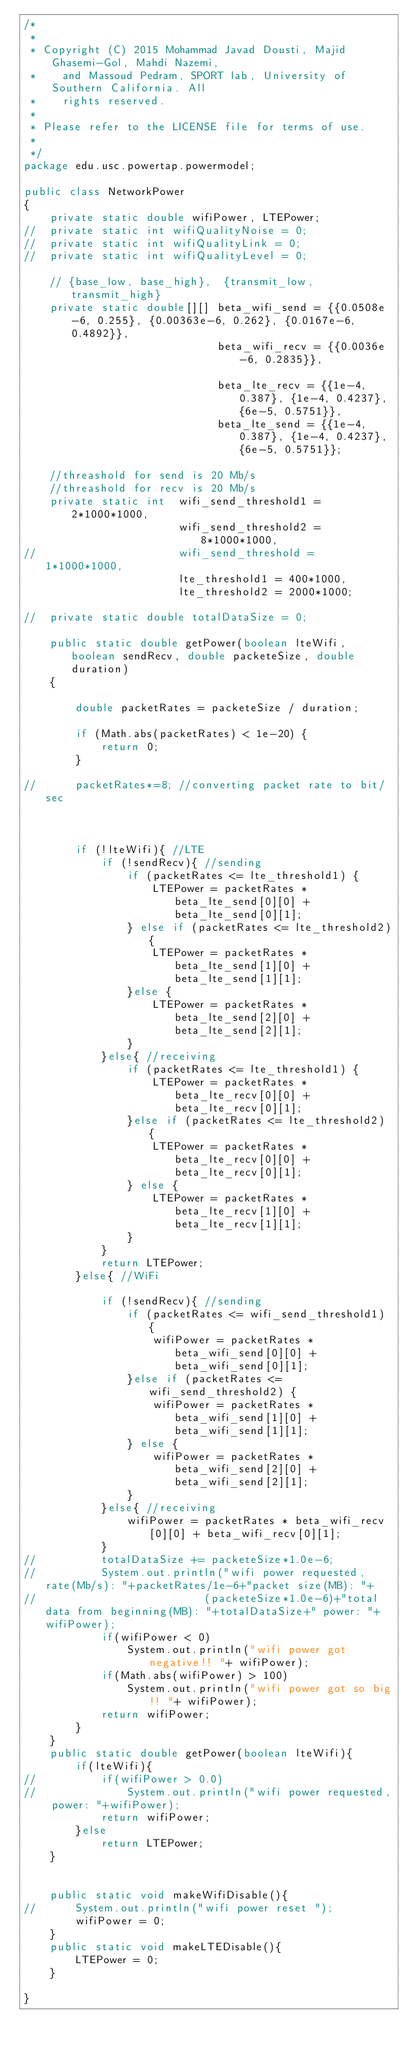Convert code to text. <code><loc_0><loc_0><loc_500><loc_500><_Java_>/*
 *
 * Copyright (C) 2015 Mohammad Javad Dousti, Majid Ghasemi-Gol, Mahdi Nazemi, 
 *    and Massoud Pedram, SPORT lab, University of Southern California. All 
 *    rights reserved.
 * 
 * Please refer to the LICENSE file for terms of use.
 *
 */
package edu.usc.powertap.powermodel;

public class NetworkPower
{	
	private static double wifiPower, LTEPower;
//	private static int wifiQualityNoise = 0;
//	private static int wifiQualityLink = 0;
//	private static int wifiQualityLevel = 0;

	// {base_low, base_high},  {transmit_low, transmit_high}
	private static double[][] beta_wifi_send = {{0.0508e-6, 0.255}, {0.00363e-6, 0.262}, {0.0167e-6, 0.4892}},
							  beta_wifi_recv = {{0.0036e-6, 0.2835}},
							  
							  beta_lte_recv = {{1e-4, 0.387}, {1e-4, 0.4237}, {6e-5, 0.5751}},
							  beta_lte_send = {{1e-4, 0.387}, {1e-4, 0.4237}, {6e-5, 0.5751}};
	
	//threashold for send is 20 Mb/s
	//threashold for recv is 20 Mb/s
	private static int 	wifi_send_threshold1 = 2*1000*1000, 
						wifi_send_threshold2 = 8*1000*1000, 
//						wifi_send_threshold = 1*1000*1000,
						lte_threshold1 = 400*1000, 
						lte_threshold2 = 2000*1000;
	
//	private static double totalDataSize = 0;

	public static double getPower(boolean lteWifi, boolean sendRecv, double packeteSize, double duration)
	{
		
		double packetRates = packeteSize / duration;
			
		if (Math.abs(packetRates) < 1e-20) {
			return 0;
		}
		
//		packetRates*=8;	//converting packet rate to bit/sec
		
		
		
		if (!lteWifi){ //LTE
			if (!sendRecv){ //sending
				if (packetRates <= lte_threshold1) {
					LTEPower = packetRates * beta_lte_send[0][0] + beta_lte_send[0][1];
				} else if (packetRates <= lte_threshold2){
					LTEPower = packetRates * beta_lte_send[1][0] + beta_lte_send[1][1];
				}else {
					LTEPower = packetRates * beta_lte_send[2][0] + beta_lte_send[2][1];
				}
			}else{ //receiving
				if (packetRates <= lte_threshold1) {
					LTEPower = packetRates * beta_lte_recv[0][0] + beta_lte_recv[0][1];
				}else if (packetRates <= lte_threshold2) {
					LTEPower = packetRates * beta_lte_recv[0][0] + beta_lte_recv[0][1];
				} else {
					LTEPower = packetRates * beta_lte_recv[1][0] + beta_lte_recv[1][1];
				}
			}
			return LTEPower;
		}else{ //WiFi
			
			if (!sendRecv){ //sending
				if (packetRates <= wifi_send_threshold1) {
					wifiPower = packetRates * beta_wifi_send[0][0] + beta_wifi_send[0][1];
				}else if (packetRates <= wifi_send_threshold2) {
					wifiPower = packetRates * beta_wifi_send[1][0] + beta_wifi_send[1][1];
				} else {
					wifiPower = packetRates * beta_wifi_send[2][0] + beta_wifi_send[2][1];
				}
			}else{ //receiving
				wifiPower = packetRates * beta_wifi_recv[0][0] + beta_wifi_recv[0][1];
			}
//			totalDataSize += packeteSize*1.0e-6;
//			System.out.println("wifi power requested, rate(Mb/s): "+packetRates/1e-6+"packet size(MB): "+
//							(packeteSize*1.0e-6)+"total data from beginning(MB): "+totalDataSize+" power: "+wifiPower);
			if(wifiPower < 0)
				System.out.println("wifi power got negative!! "+ wifiPower);
			if(Math.abs(wifiPower) > 100)
				System.out.println("wifi power got so big!! "+ wifiPower);
			return wifiPower;
		}
	}
	public static double getPower(boolean lteWifi){
		if(lteWifi){
//			if(wifiPower > 0.0)
//				System.out.println("wifi power requested, power: "+wifiPower);
			return wifiPower;
		}else 
			return LTEPower;
	}			
	
	
	public static void makeWifiDisable(){
//		System.out.println("wifi power reset ");
		wifiPower = 0;
	}
	public static void makeLTEDisable(){
		LTEPower = 0;
	}

}</code> 